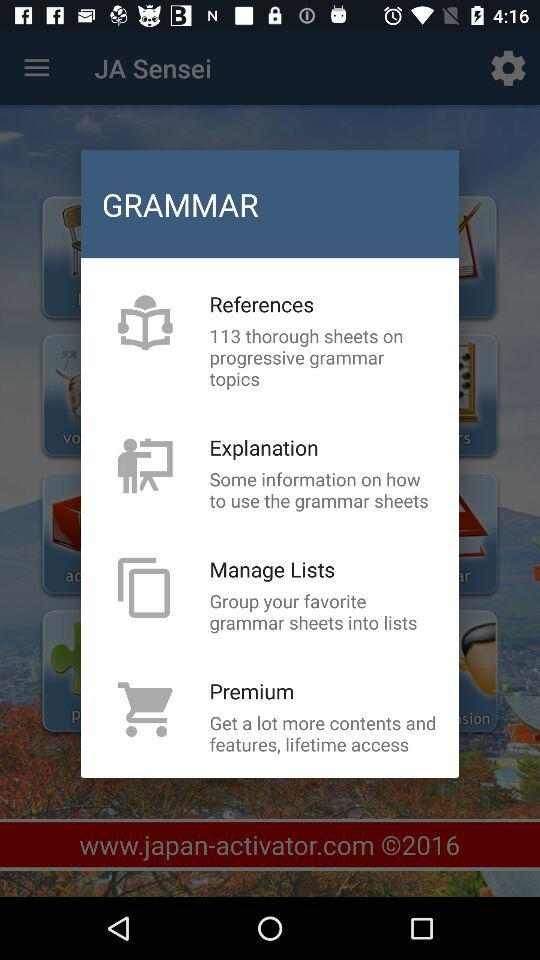How many items are there on the grammar screen?
Answer the question using a single word or phrase. 4 